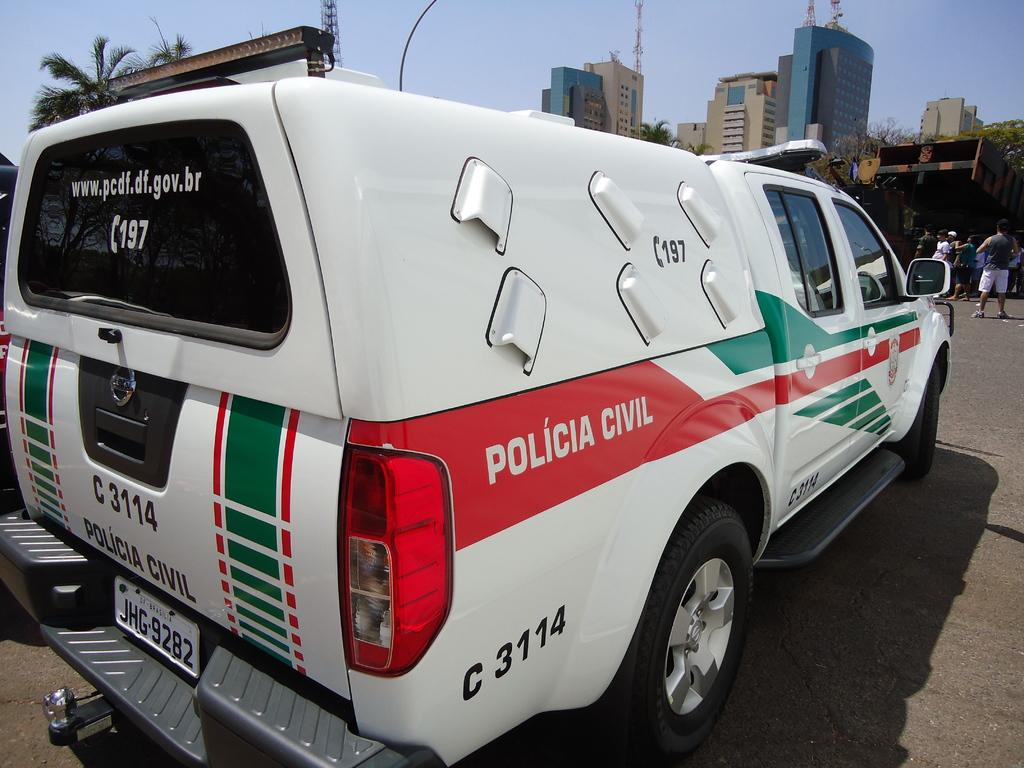<image>
Describe the image concisely. White and red van that says "Policia Civil" on the back. 